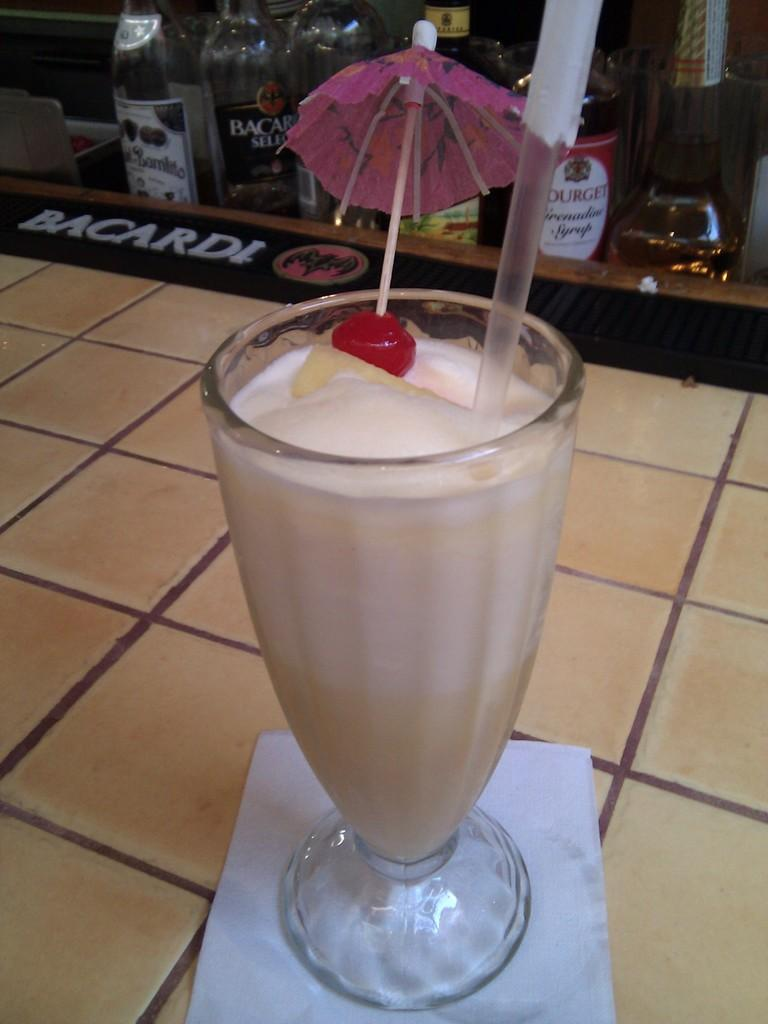What objects are on the floor in the image? There is a bottle, an umbrella, and a glass on the floor. What type of war is being depicted in the image? There is no depiction of war in the image; it features a bottle, an umbrella, and a glass on the floor. What type of shade is provided by the umbrella in the image? The image does not show the umbrella providing any shade, as it is on the floor. 